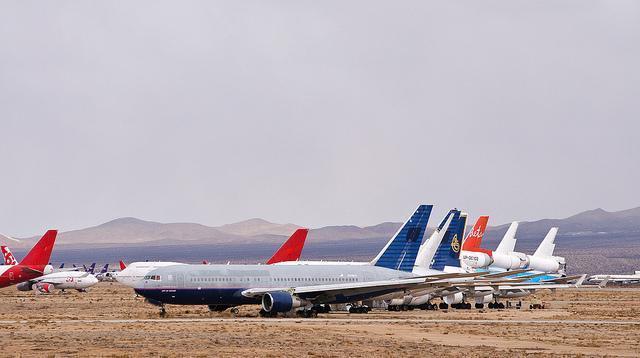How many airplanes can you see?
Give a very brief answer. 2. How many people are playing the game?
Give a very brief answer. 0. 